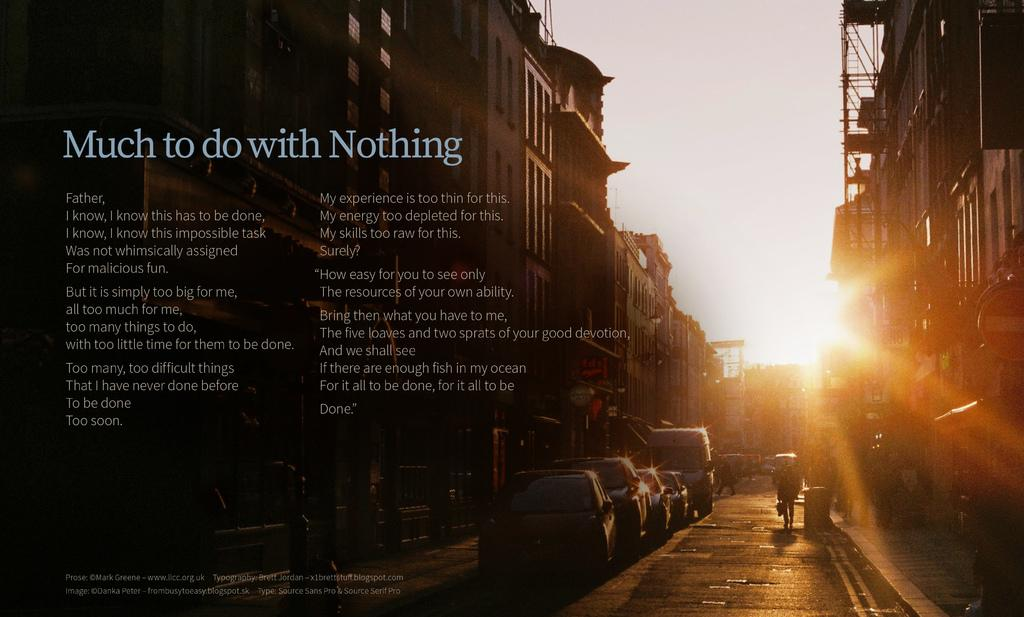What type of structures can be seen in the image? There are buildings in the image. What else is visible besides the buildings? There are vehicles and people in the image. What can be seen in the background of the image? The sky is visible in the background of the image, and the sun is also visible. Is there any text or writing present in the image? Yes, there is text or writing present in the image. How many balloons are being held by the people in the image? There are no balloons visible in the image; the people are not holding any. What type of rings can be seen on the fingers of the people in the image? There are no rings visible on the fingers of the people in the image. 